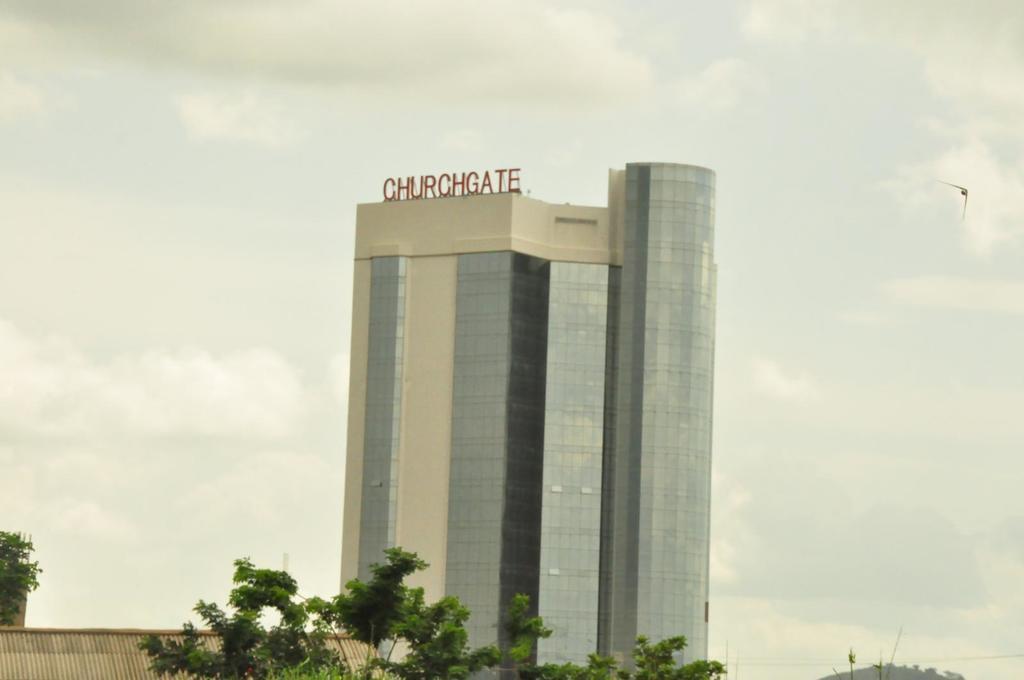How would you summarize this image in a sentence or two? In the image we can see a building which is made up of glass. Here we can see text, trees and the cloudy sky. We can even see a bird flying. 